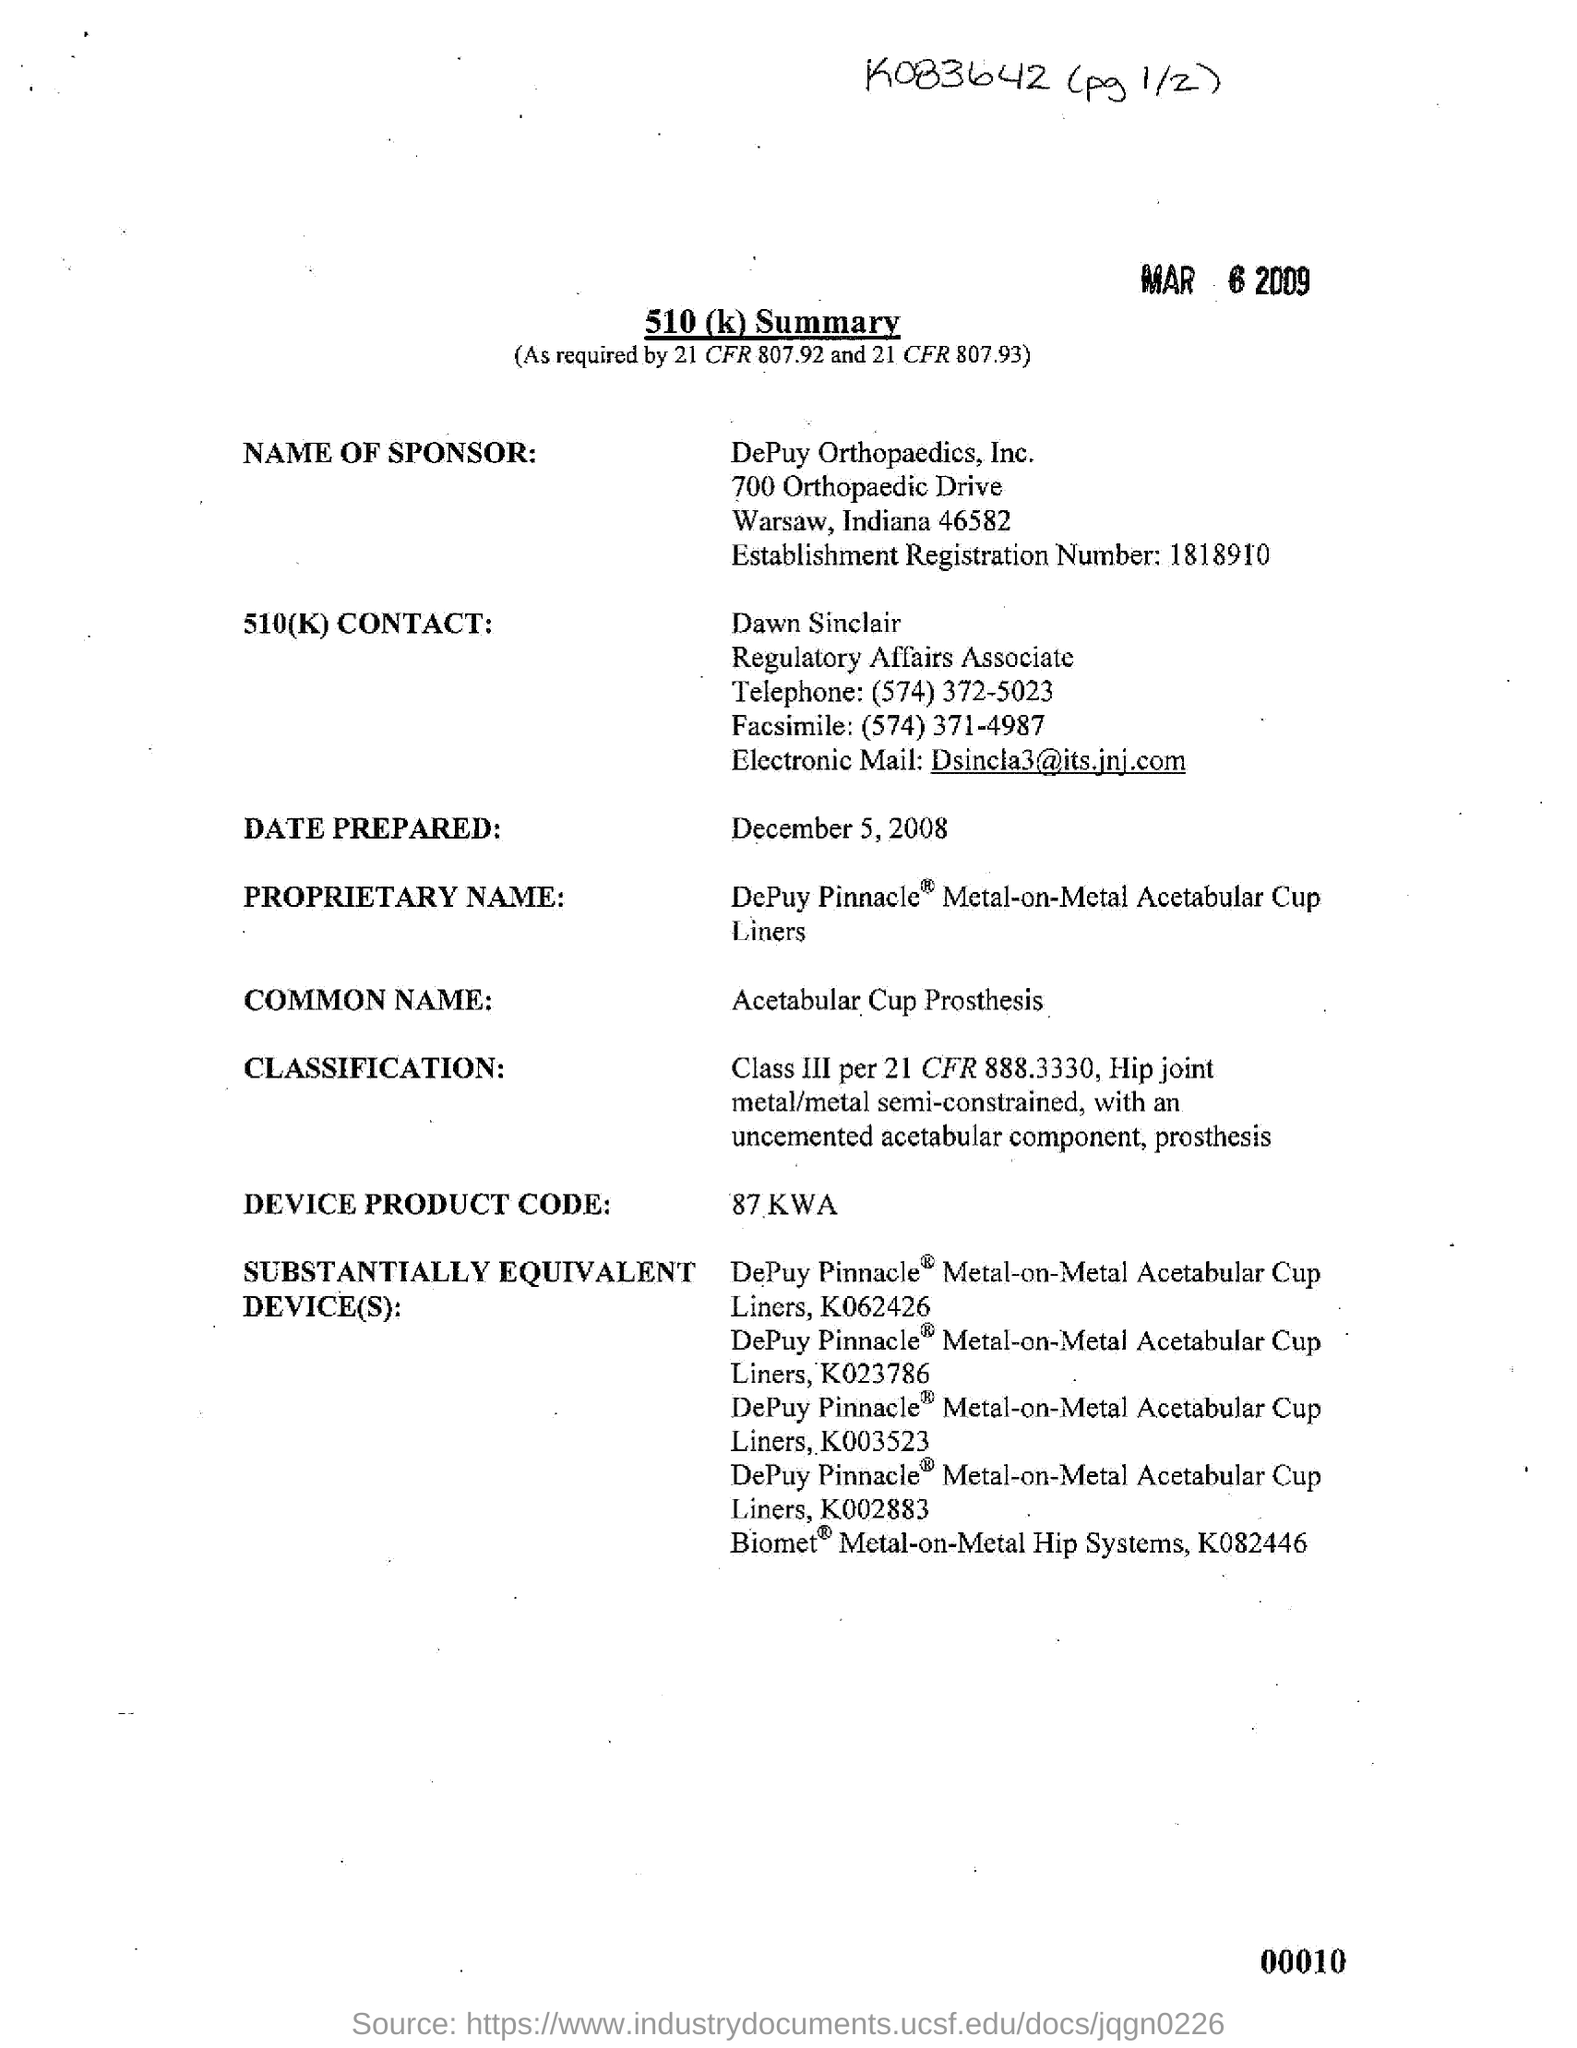Mention a couple of crucial points in this snapshot. DePuy Orthopaedics, Inc. is located in the state of Indiana. The telephone number of Dawn Sinclair is (574) 372-5023. The facsimile number is (574) 371-4987. The establishment registration number is 1818910... The date prepared is December 5, 2008. 